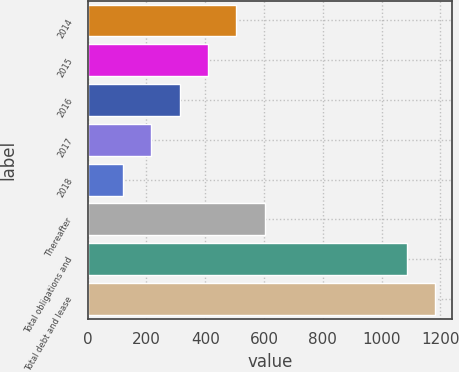Convert chart to OTSL. <chart><loc_0><loc_0><loc_500><loc_500><bar_chart><fcel>2014<fcel>2015<fcel>2016<fcel>2017<fcel>2018<fcel>Thereafter<fcel>Total obligations and<fcel>Total debt and lease<nl><fcel>506<fcel>409.5<fcel>313<fcel>216.5<fcel>120<fcel>602.5<fcel>1085<fcel>1181.5<nl></chart> 